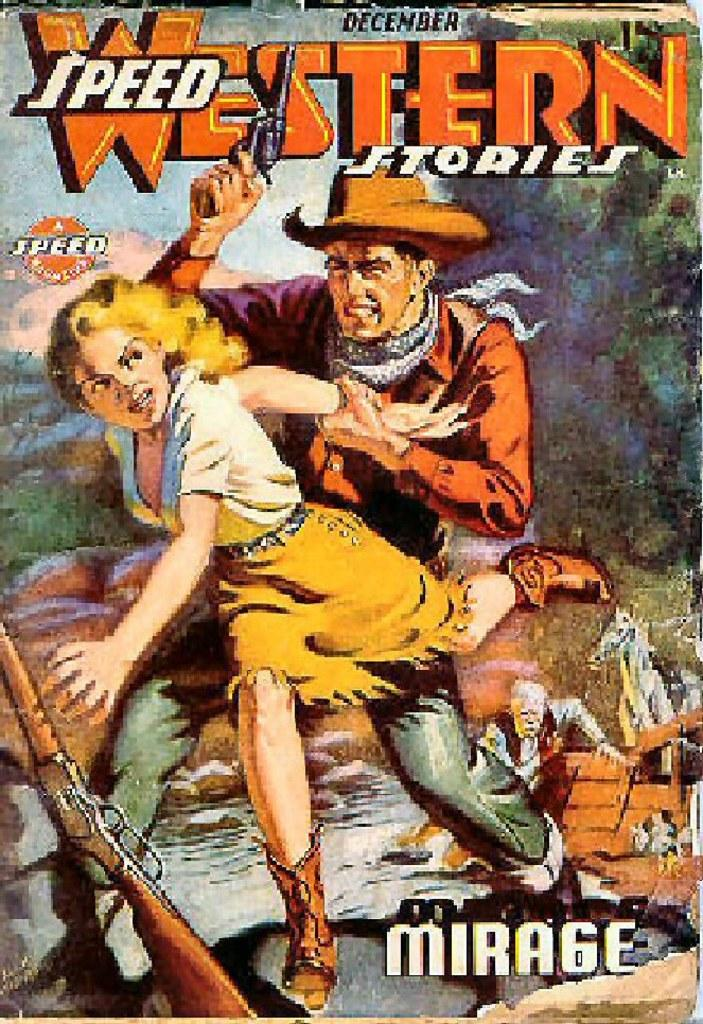<image>
Present a compact description of the photo's key features. Western comic called Speed Western Stories for December. 